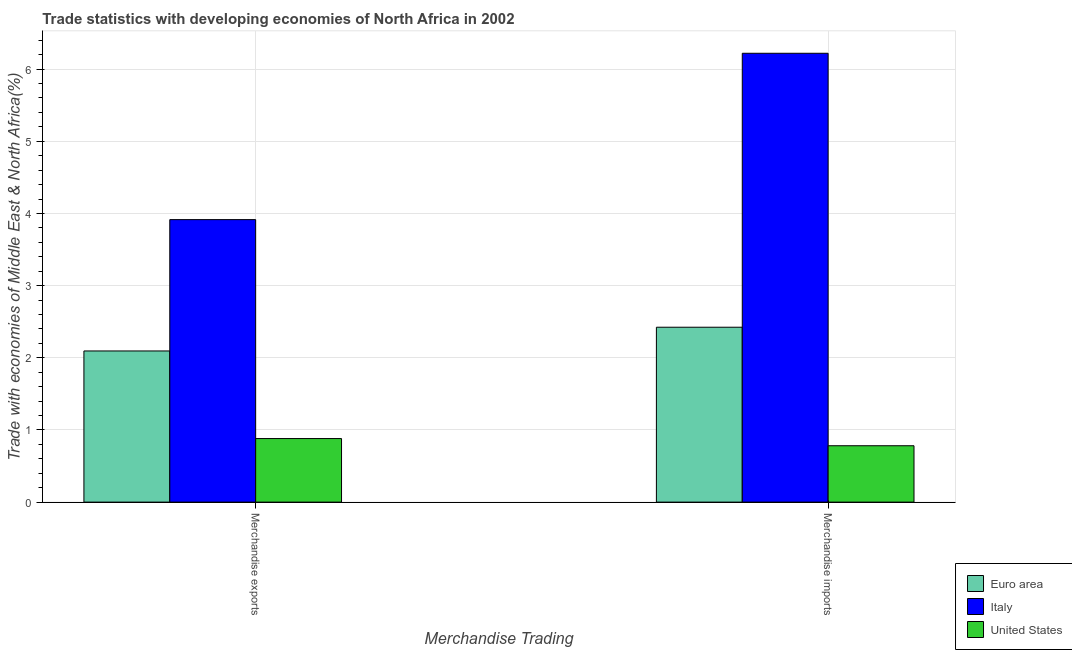How many different coloured bars are there?
Make the answer very short. 3. How many groups of bars are there?
Provide a short and direct response. 2. Are the number of bars per tick equal to the number of legend labels?
Offer a terse response. Yes. How many bars are there on the 2nd tick from the right?
Provide a succinct answer. 3. What is the label of the 1st group of bars from the left?
Your answer should be compact. Merchandise exports. What is the merchandise imports in Italy?
Your answer should be compact. 6.22. Across all countries, what is the maximum merchandise imports?
Ensure brevity in your answer.  6.22. Across all countries, what is the minimum merchandise exports?
Your answer should be very brief. 0.88. In which country was the merchandise imports maximum?
Offer a very short reply. Italy. What is the total merchandise imports in the graph?
Your response must be concise. 9.42. What is the difference between the merchandise imports in United States and that in Italy?
Offer a terse response. -5.44. What is the difference between the merchandise imports in Euro area and the merchandise exports in United States?
Make the answer very short. 1.54. What is the average merchandise exports per country?
Your response must be concise. 2.3. What is the difference between the merchandise exports and merchandise imports in United States?
Your answer should be very brief. 0.1. What is the ratio of the merchandise exports in Italy to that in Euro area?
Make the answer very short. 1.87. In how many countries, is the merchandise exports greater than the average merchandise exports taken over all countries?
Offer a terse response. 1. What does the 2nd bar from the right in Merchandise imports represents?
Keep it short and to the point. Italy. How many bars are there?
Give a very brief answer. 6. How many countries are there in the graph?
Make the answer very short. 3. What is the difference between two consecutive major ticks on the Y-axis?
Ensure brevity in your answer.  1. Does the graph contain any zero values?
Offer a terse response. No. Where does the legend appear in the graph?
Offer a very short reply. Bottom right. How many legend labels are there?
Your answer should be compact. 3. What is the title of the graph?
Offer a very short reply. Trade statistics with developing economies of North Africa in 2002. What is the label or title of the X-axis?
Provide a short and direct response. Merchandise Trading. What is the label or title of the Y-axis?
Provide a short and direct response. Trade with economies of Middle East & North Africa(%). What is the Trade with economies of Middle East & North Africa(%) in Euro area in Merchandise exports?
Provide a short and direct response. 2.09. What is the Trade with economies of Middle East & North Africa(%) in Italy in Merchandise exports?
Keep it short and to the point. 3.91. What is the Trade with economies of Middle East & North Africa(%) of United States in Merchandise exports?
Offer a very short reply. 0.88. What is the Trade with economies of Middle East & North Africa(%) in Euro area in Merchandise imports?
Provide a succinct answer. 2.42. What is the Trade with economies of Middle East & North Africa(%) of Italy in Merchandise imports?
Keep it short and to the point. 6.22. What is the Trade with economies of Middle East & North Africa(%) of United States in Merchandise imports?
Your answer should be very brief. 0.78. Across all Merchandise Trading, what is the maximum Trade with economies of Middle East & North Africa(%) of Euro area?
Offer a very short reply. 2.42. Across all Merchandise Trading, what is the maximum Trade with economies of Middle East & North Africa(%) of Italy?
Offer a very short reply. 6.22. Across all Merchandise Trading, what is the maximum Trade with economies of Middle East & North Africa(%) in United States?
Keep it short and to the point. 0.88. Across all Merchandise Trading, what is the minimum Trade with economies of Middle East & North Africa(%) of Euro area?
Keep it short and to the point. 2.09. Across all Merchandise Trading, what is the minimum Trade with economies of Middle East & North Africa(%) of Italy?
Ensure brevity in your answer.  3.91. Across all Merchandise Trading, what is the minimum Trade with economies of Middle East & North Africa(%) in United States?
Make the answer very short. 0.78. What is the total Trade with economies of Middle East & North Africa(%) in Euro area in the graph?
Ensure brevity in your answer.  4.52. What is the total Trade with economies of Middle East & North Africa(%) of Italy in the graph?
Your answer should be very brief. 10.13. What is the total Trade with economies of Middle East & North Africa(%) in United States in the graph?
Make the answer very short. 1.66. What is the difference between the Trade with economies of Middle East & North Africa(%) of Euro area in Merchandise exports and that in Merchandise imports?
Provide a succinct answer. -0.33. What is the difference between the Trade with economies of Middle East & North Africa(%) in Italy in Merchandise exports and that in Merchandise imports?
Give a very brief answer. -2.31. What is the difference between the Trade with economies of Middle East & North Africa(%) of United States in Merchandise exports and that in Merchandise imports?
Keep it short and to the point. 0.1. What is the difference between the Trade with economies of Middle East & North Africa(%) of Euro area in Merchandise exports and the Trade with economies of Middle East & North Africa(%) of Italy in Merchandise imports?
Ensure brevity in your answer.  -4.12. What is the difference between the Trade with economies of Middle East & North Africa(%) of Euro area in Merchandise exports and the Trade with economies of Middle East & North Africa(%) of United States in Merchandise imports?
Your answer should be very brief. 1.31. What is the difference between the Trade with economies of Middle East & North Africa(%) in Italy in Merchandise exports and the Trade with economies of Middle East & North Africa(%) in United States in Merchandise imports?
Provide a succinct answer. 3.13. What is the average Trade with economies of Middle East & North Africa(%) of Euro area per Merchandise Trading?
Your response must be concise. 2.26. What is the average Trade with economies of Middle East & North Africa(%) in Italy per Merchandise Trading?
Provide a succinct answer. 5.07. What is the average Trade with economies of Middle East & North Africa(%) of United States per Merchandise Trading?
Offer a very short reply. 0.83. What is the difference between the Trade with economies of Middle East & North Africa(%) in Euro area and Trade with economies of Middle East & North Africa(%) in Italy in Merchandise exports?
Offer a terse response. -1.82. What is the difference between the Trade with economies of Middle East & North Africa(%) in Euro area and Trade with economies of Middle East & North Africa(%) in United States in Merchandise exports?
Your answer should be very brief. 1.21. What is the difference between the Trade with economies of Middle East & North Africa(%) of Italy and Trade with economies of Middle East & North Africa(%) of United States in Merchandise exports?
Your response must be concise. 3.03. What is the difference between the Trade with economies of Middle East & North Africa(%) of Euro area and Trade with economies of Middle East & North Africa(%) of Italy in Merchandise imports?
Give a very brief answer. -3.8. What is the difference between the Trade with economies of Middle East & North Africa(%) in Euro area and Trade with economies of Middle East & North Africa(%) in United States in Merchandise imports?
Make the answer very short. 1.64. What is the difference between the Trade with economies of Middle East & North Africa(%) in Italy and Trade with economies of Middle East & North Africa(%) in United States in Merchandise imports?
Your answer should be compact. 5.44. What is the ratio of the Trade with economies of Middle East & North Africa(%) of Euro area in Merchandise exports to that in Merchandise imports?
Your answer should be very brief. 0.86. What is the ratio of the Trade with economies of Middle East & North Africa(%) of Italy in Merchandise exports to that in Merchandise imports?
Make the answer very short. 0.63. What is the ratio of the Trade with economies of Middle East & North Africa(%) of United States in Merchandise exports to that in Merchandise imports?
Offer a very short reply. 1.13. What is the difference between the highest and the second highest Trade with economies of Middle East & North Africa(%) of Euro area?
Provide a succinct answer. 0.33. What is the difference between the highest and the second highest Trade with economies of Middle East & North Africa(%) of Italy?
Your answer should be compact. 2.31. What is the difference between the highest and the second highest Trade with economies of Middle East & North Africa(%) of United States?
Offer a very short reply. 0.1. What is the difference between the highest and the lowest Trade with economies of Middle East & North Africa(%) in Euro area?
Provide a succinct answer. 0.33. What is the difference between the highest and the lowest Trade with economies of Middle East & North Africa(%) in Italy?
Your answer should be compact. 2.31. What is the difference between the highest and the lowest Trade with economies of Middle East & North Africa(%) in United States?
Offer a very short reply. 0.1. 